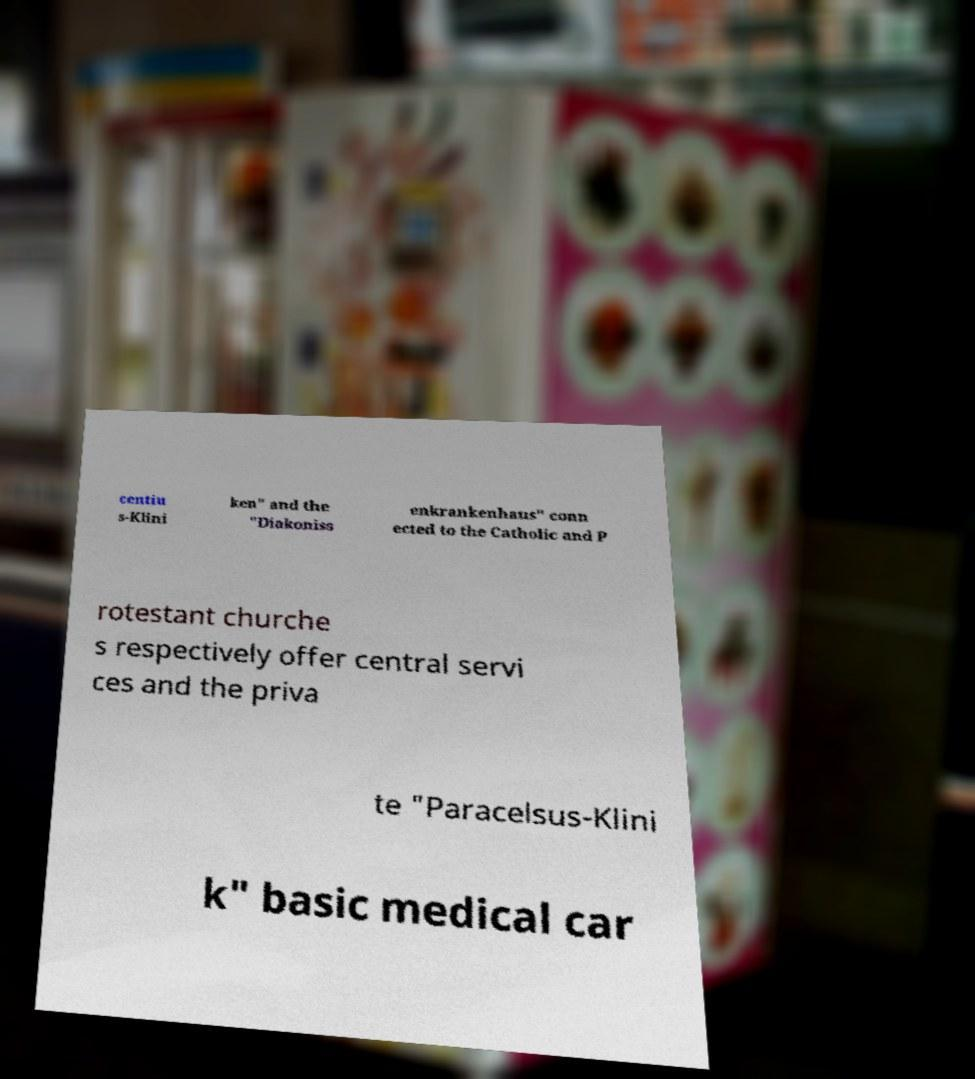What messages or text are displayed in this image? I need them in a readable, typed format. centiu s-Klini ken" and the "Diakoniss enkrankenhaus" conn ected to the Catholic and P rotestant churche s respectively offer central servi ces and the priva te "Paracelsus-Klini k" basic medical car 